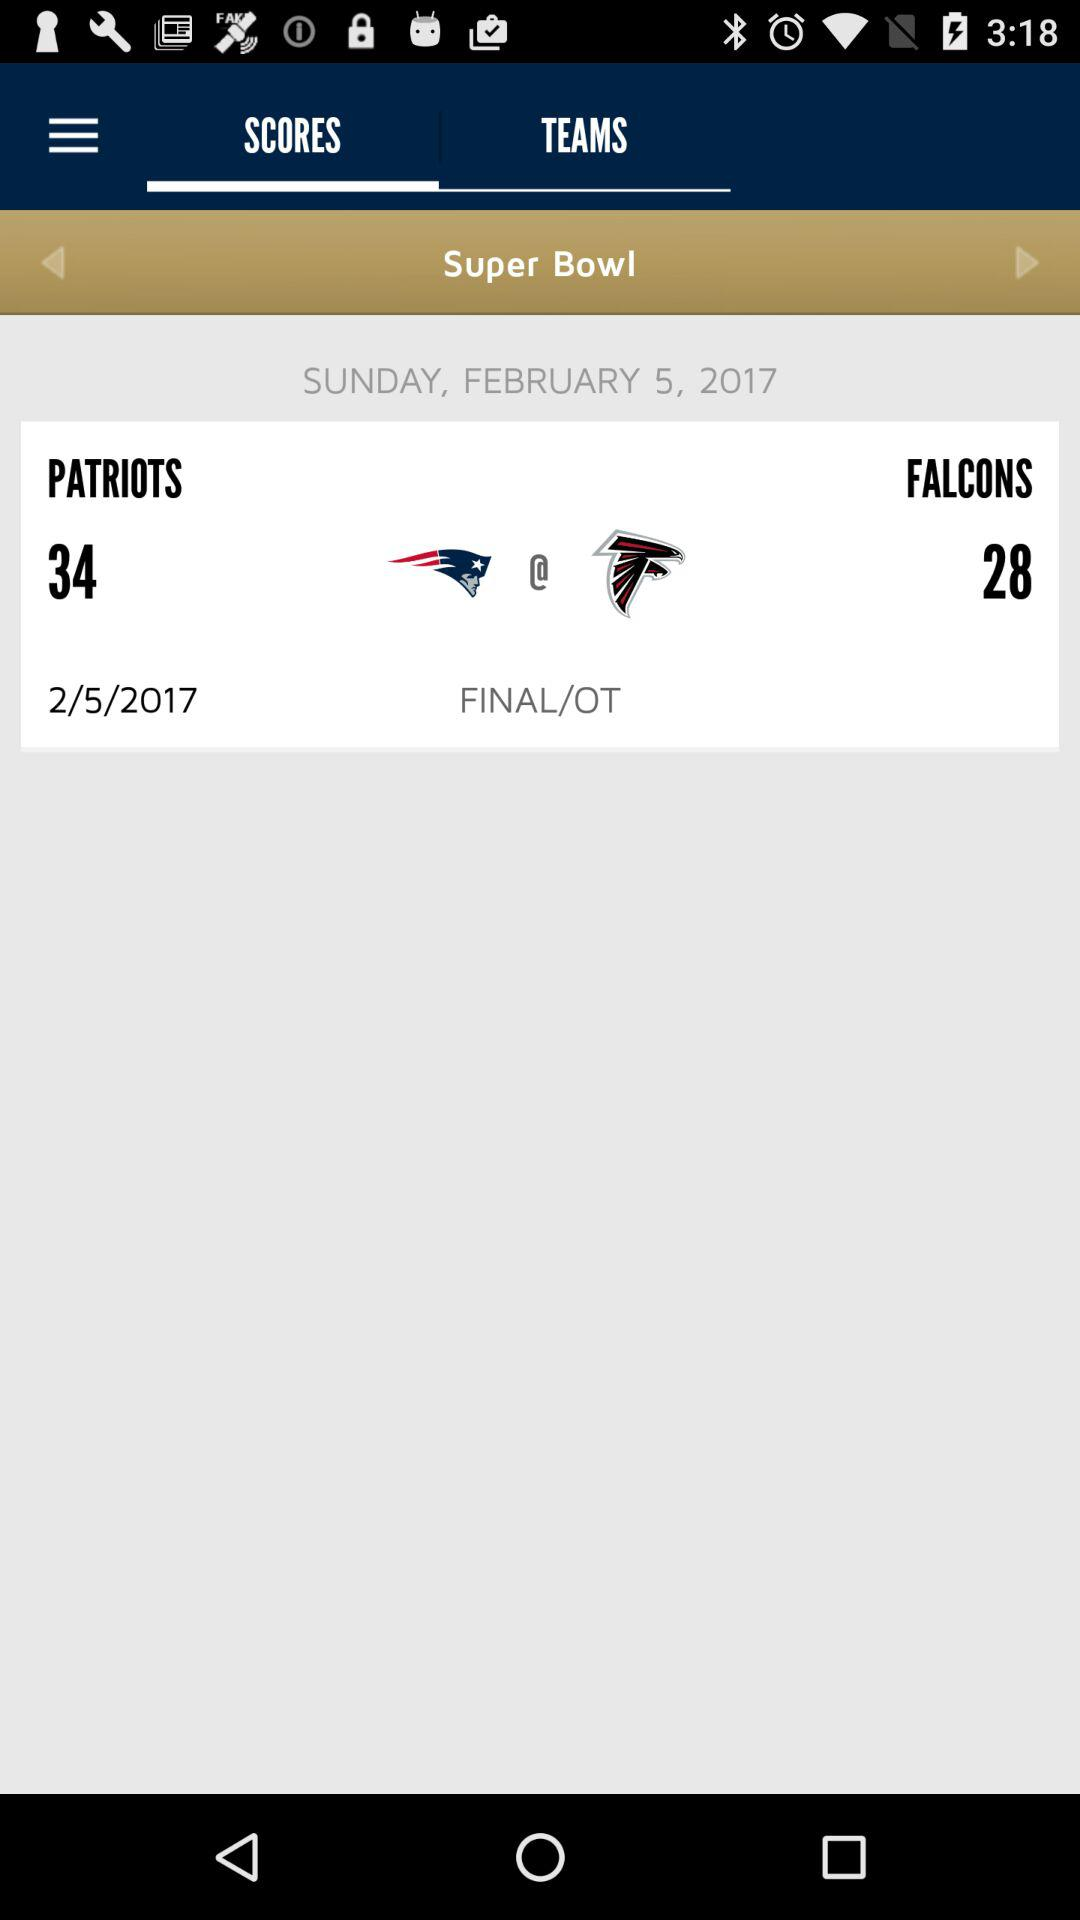How many points did the Patriots score in the first half?
Answer the question using a single word or phrase. 34 